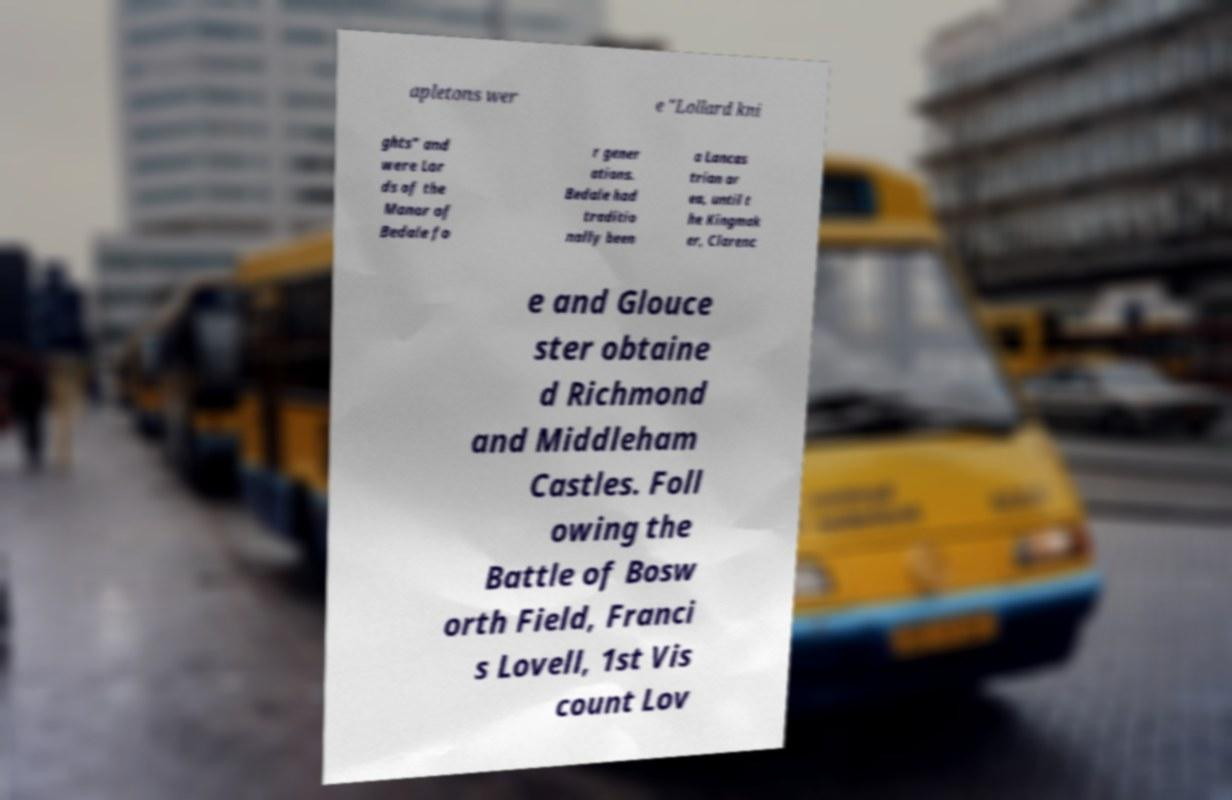Please identify and transcribe the text found in this image. apletons wer e "Lollard kni ghts" and were Lor ds of the Manor of Bedale fo r gener ations. Bedale had traditio nally been a Lancas trian ar ea, until t he Kingmak er, Clarenc e and Glouce ster obtaine d Richmond and Middleham Castles. Foll owing the Battle of Bosw orth Field, Franci s Lovell, 1st Vis count Lov 